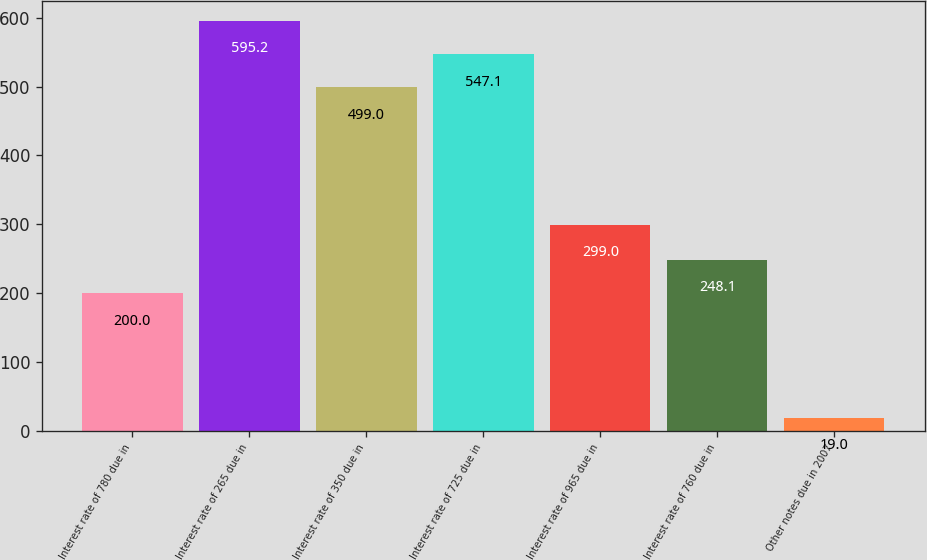<chart> <loc_0><loc_0><loc_500><loc_500><bar_chart><fcel>Interest rate of 780 due in<fcel>Interest rate of 265 due in<fcel>Interest rate of 350 due in<fcel>Interest rate of 725 due in<fcel>Interest rate of 965 due in<fcel>Interest rate of 760 due in<fcel>Other notes due in 2007<nl><fcel>200<fcel>595.2<fcel>499<fcel>547.1<fcel>299<fcel>248.1<fcel>19<nl></chart> 